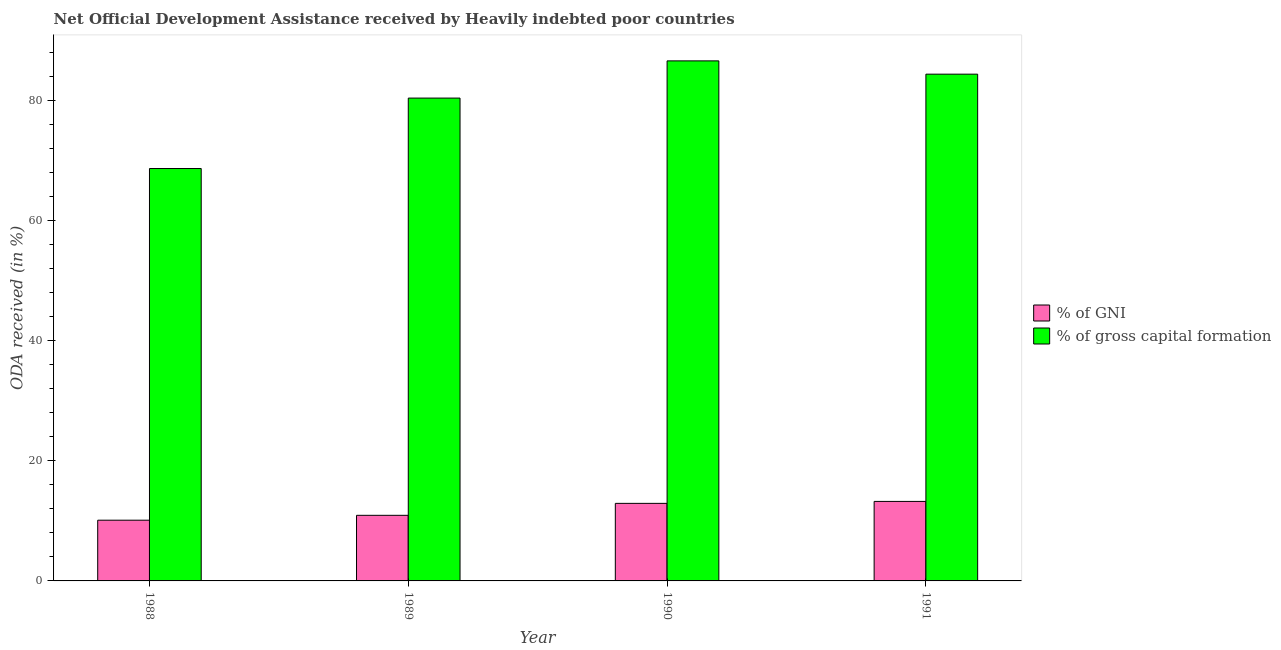How many groups of bars are there?
Ensure brevity in your answer.  4. How many bars are there on the 4th tick from the right?
Provide a short and direct response. 2. What is the label of the 2nd group of bars from the left?
Your answer should be compact. 1989. In how many cases, is the number of bars for a given year not equal to the number of legend labels?
Offer a very short reply. 0. What is the oda received as percentage of gni in 1990?
Your answer should be compact. 12.92. Across all years, what is the maximum oda received as percentage of gross capital formation?
Ensure brevity in your answer.  86.64. Across all years, what is the minimum oda received as percentage of gni?
Provide a short and direct response. 10.12. In which year was the oda received as percentage of gross capital formation minimum?
Your answer should be very brief. 1988. What is the total oda received as percentage of gni in the graph?
Provide a short and direct response. 47.21. What is the difference between the oda received as percentage of gross capital formation in 1989 and that in 1991?
Make the answer very short. -3.99. What is the difference between the oda received as percentage of gni in 1990 and the oda received as percentage of gross capital formation in 1989?
Your answer should be compact. 1.99. What is the average oda received as percentage of gni per year?
Keep it short and to the point. 11.8. In the year 1988, what is the difference between the oda received as percentage of gni and oda received as percentage of gross capital formation?
Offer a terse response. 0. What is the ratio of the oda received as percentage of gross capital formation in 1990 to that in 1991?
Ensure brevity in your answer.  1.03. Is the difference between the oda received as percentage of gni in 1989 and 1990 greater than the difference between the oda received as percentage of gross capital formation in 1989 and 1990?
Offer a very short reply. No. What is the difference between the highest and the second highest oda received as percentage of gni?
Keep it short and to the point. 0.33. What is the difference between the highest and the lowest oda received as percentage of gni?
Provide a succinct answer. 3.13. In how many years, is the oda received as percentage of gross capital formation greater than the average oda received as percentage of gross capital formation taken over all years?
Your response must be concise. 3. What does the 1st bar from the left in 1990 represents?
Give a very brief answer. % of GNI. What does the 1st bar from the right in 1990 represents?
Offer a terse response. % of gross capital formation. How many bars are there?
Your answer should be compact. 8. What is the difference between two consecutive major ticks on the Y-axis?
Give a very brief answer. 20. Does the graph contain grids?
Offer a terse response. No. How many legend labels are there?
Provide a short and direct response. 2. What is the title of the graph?
Make the answer very short. Net Official Development Assistance received by Heavily indebted poor countries. What is the label or title of the Y-axis?
Offer a terse response. ODA received (in %). What is the ODA received (in %) in % of GNI in 1988?
Make the answer very short. 10.12. What is the ODA received (in %) of % of gross capital formation in 1988?
Ensure brevity in your answer.  68.7. What is the ODA received (in %) of % of GNI in 1989?
Offer a terse response. 10.93. What is the ODA received (in %) of % of gross capital formation in 1989?
Offer a very short reply. 80.44. What is the ODA received (in %) of % of GNI in 1990?
Your answer should be compact. 12.92. What is the ODA received (in %) of % of gross capital formation in 1990?
Provide a short and direct response. 86.64. What is the ODA received (in %) of % of GNI in 1991?
Give a very brief answer. 13.25. What is the ODA received (in %) in % of gross capital formation in 1991?
Keep it short and to the point. 84.43. Across all years, what is the maximum ODA received (in %) in % of GNI?
Your answer should be compact. 13.25. Across all years, what is the maximum ODA received (in %) in % of gross capital formation?
Your response must be concise. 86.64. Across all years, what is the minimum ODA received (in %) in % of GNI?
Give a very brief answer. 10.12. Across all years, what is the minimum ODA received (in %) of % of gross capital formation?
Make the answer very short. 68.7. What is the total ODA received (in %) in % of GNI in the graph?
Ensure brevity in your answer.  47.21. What is the total ODA received (in %) of % of gross capital formation in the graph?
Offer a terse response. 320.21. What is the difference between the ODA received (in %) in % of GNI in 1988 and that in 1989?
Provide a succinct answer. -0.81. What is the difference between the ODA received (in %) of % of gross capital formation in 1988 and that in 1989?
Ensure brevity in your answer.  -11.73. What is the difference between the ODA received (in %) of % of GNI in 1988 and that in 1990?
Offer a very short reply. -2.8. What is the difference between the ODA received (in %) in % of gross capital formation in 1988 and that in 1990?
Your answer should be very brief. -17.93. What is the difference between the ODA received (in %) of % of GNI in 1988 and that in 1991?
Keep it short and to the point. -3.13. What is the difference between the ODA received (in %) of % of gross capital formation in 1988 and that in 1991?
Offer a very short reply. -15.72. What is the difference between the ODA received (in %) of % of GNI in 1989 and that in 1990?
Provide a short and direct response. -1.99. What is the difference between the ODA received (in %) in % of gross capital formation in 1989 and that in 1990?
Provide a succinct answer. -6.2. What is the difference between the ODA received (in %) of % of GNI in 1989 and that in 1991?
Offer a very short reply. -2.32. What is the difference between the ODA received (in %) of % of gross capital formation in 1989 and that in 1991?
Give a very brief answer. -3.99. What is the difference between the ODA received (in %) of % of GNI in 1990 and that in 1991?
Ensure brevity in your answer.  -0.33. What is the difference between the ODA received (in %) of % of gross capital formation in 1990 and that in 1991?
Your answer should be very brief. 2.21. What is the difference between the ODA received (in %) of % of GNI in 1988 and the ODA received (in %) of % of gross capital formation in 1989?
Your response must be concise. -70.32. What is the difference between the ODA received (in %) in % of GNI in 1988 and the ODA received (in %) in % of gross capital formation in 1990?
Offer a very short reply. -76.52. What is the difference between the ODA received (in %) of % of GNI in 1988 and the ODA received (in %) of % of gross capital formation in 1991?
Keep it short and to the point. -74.31. What is the difference between the ODA received (in %) in % of GNI in 1989 and the ODA received (in %) in % of gross capital formation in 1990?
Ensure brevity in your answer.  -75.71. What is the difference between the ODA received (in %) of % of GNI in 1989 and the ODA received (in %) of % of gross capital formation in 1991?
Provide a short and direct response. -73.5. What is the difference between the ODA received (in %) in % of GNI in 1990 and the ODA received (in %) in % of gross capital formation in 1991?
Keep it short and to the point. -71.51. What is the average ODA received (in %) in % of GNI per year?
Your answer should be compact. 11.8. What is the average ODA received (in %) in % of gross capital formation per year?
Give a very brief answer. 80.05. In the year 1988, what is the difference between the ODA received (in %) in % of GNI and ODA received (in %) in % of gross capital formation?
Make the answer very short. -58.59. In the year 1989, what is the difference between the ODA received (in %) in % of GNI and ODA received (in %) in % of gross capital formation?
Ensure brevity in your answer.  -69.51. In the year 1990, what is the difference between the ODA received (in %) in % of GNI and ODA received (in %) in % of gross capital formation?
Offer a very short reply. -73.72. In the year 1991, what is the difference between the ODA received (in %) in % of GNI and ODA received (in %) in % of gross capital formation?
Ensure brevity in your answer.  -71.18. What is the ratio of the ODA received (in %) in % of GNI in 1988 to that in 1989?
Provide a succinct answer. 0.93. What is the ratio of the ODA received (in %) in % of gross capital formation in 1988 to that in 1989?
Provide a succinct answer. 0.85. What is the ratio of the ODA received (in %) in % of GNI in 1988 to that in 1990?
Offer a terse response. 0.78. What is the ratio of the ODA received (in %) of % of gross capital formation in 1988 to that in 1990?
Provide a short and direct response. 0.79. What is the ratio of the ODA received (in %) in % of GNI in 1988 to that in 1991?
Provide a short and direct response. 0.76. What is the ratio of the ODA received (in %) in % of gross capital formation in 1988 to that in 1991?
Offer a very short reply. 0.81. What is the ratio of the ODA received (in %) in % of GNI in 1989 to that in 1990?
Your response must be concise. 0.85. What is the ratio of the ODA received (in %) in % of gross capital formation in 1989 to that in 1990?
Make the answer very short. 0.93. What is the ratio of the ODA received (in %) in % of GNI in 1989 to that in 1991?
Provide a succinct answer. 0.83. What is the ratio of the ODA received (in %) of % of gross capital formation in 1989 to that in 1991?
Your response must be concise. 0.95. What is the ratio of the ODA received (in %) of % of GNI in 1990 to that in 1991?
Provide a short and direct response. 0.98. What is the ratio of the ODA received (in %) in % of gross capital formation in 1990 to that in 1991?
Provide a short and direct response. 1.03. What is the difference between the highest and the second highest ODA received (in %) in % of GNI?
Ensure brevity in your answer.  0.33. What is the difference between the highest and the second highest ODA received (in %) of % of gross capital formation?
Your answer should be very brief. 2.21. What is the difference between the highest and the lowest ODA received (in %) in % of GNI?
Your answer should be compact. 3.13. What is the difference between the highest and the lowest ODA received (in %) in % of gross capital formation?
Your answer should be very brief. 17.93. 